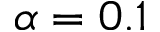<formula> <loc_0><loc_0><loc_500><loc_500>\alpha = 0 . 1</formula> 